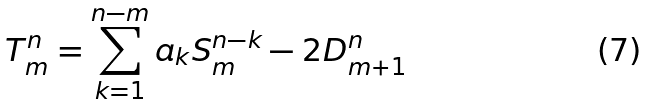<formula> <loc_0><loc_0><loc_500><loc_500>T _ { m } ^ { n } = \sum _ { k = 1 } ^ { n - m } a _ { k } S ^ { n - k } _ { m } - 2 D _ { m + 1 } ^ { n }</formula> 